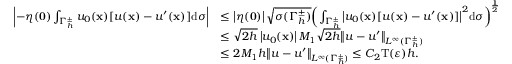<formula> <loc_0><loc_0><loc_500><loc_500>\begin{array} { r l } { \left | - \eta ( \mathbf 0 ) \int _ { { \Gamma _ { h } ^ { \pm } } } { { u _ { 0 } } ( \mathbf x ) [ u ( \mathbf x ) - u ^ { \prime } ( \mathbf x ) ] } \mathrm d \sigma \right | } & { \leq \left | \eta ( \mathbf 0 ) \right | \sqrt { \sigma ( { \Gamma _ { h } ^ { \pm } } ) } { \left ( \int _ { { \Gamma _ { h } ^ { \pm } } } { { { \left | { { u _ { 0 } } ( \mathbf x ) [ u ( \mathbf x ) - u ^ { \prime } ( \mathbf x ) ] } \right | } ^ { 2 } } } \mathrm d \sigma \right ) ^ { { \frac { 1 } { 2 } } } } } \\ & { \leq \sqrt { 2 h } \left | { { u _ { 0 } } ( \mathbf x ) } \right | M _ { 1 } \sqrt { 2 h } { \left \| { u - u ^ { \prime } } \right \| _ { { L ^ { \infty } } ( { \Gamma _ { h } ^ { \pm } } ) } } } \\ & { \leq 2 M _ { 1 } h { \left \| { u - u ^ { \prime } } \right \| _ { { L ^ { \infty } } ( { \Gamma _ { h } ^ { \pm } } ) } } \leq { C _ { 2 } } \mathrm T ( \varepsilon ) h . } \end{array}</formula> 